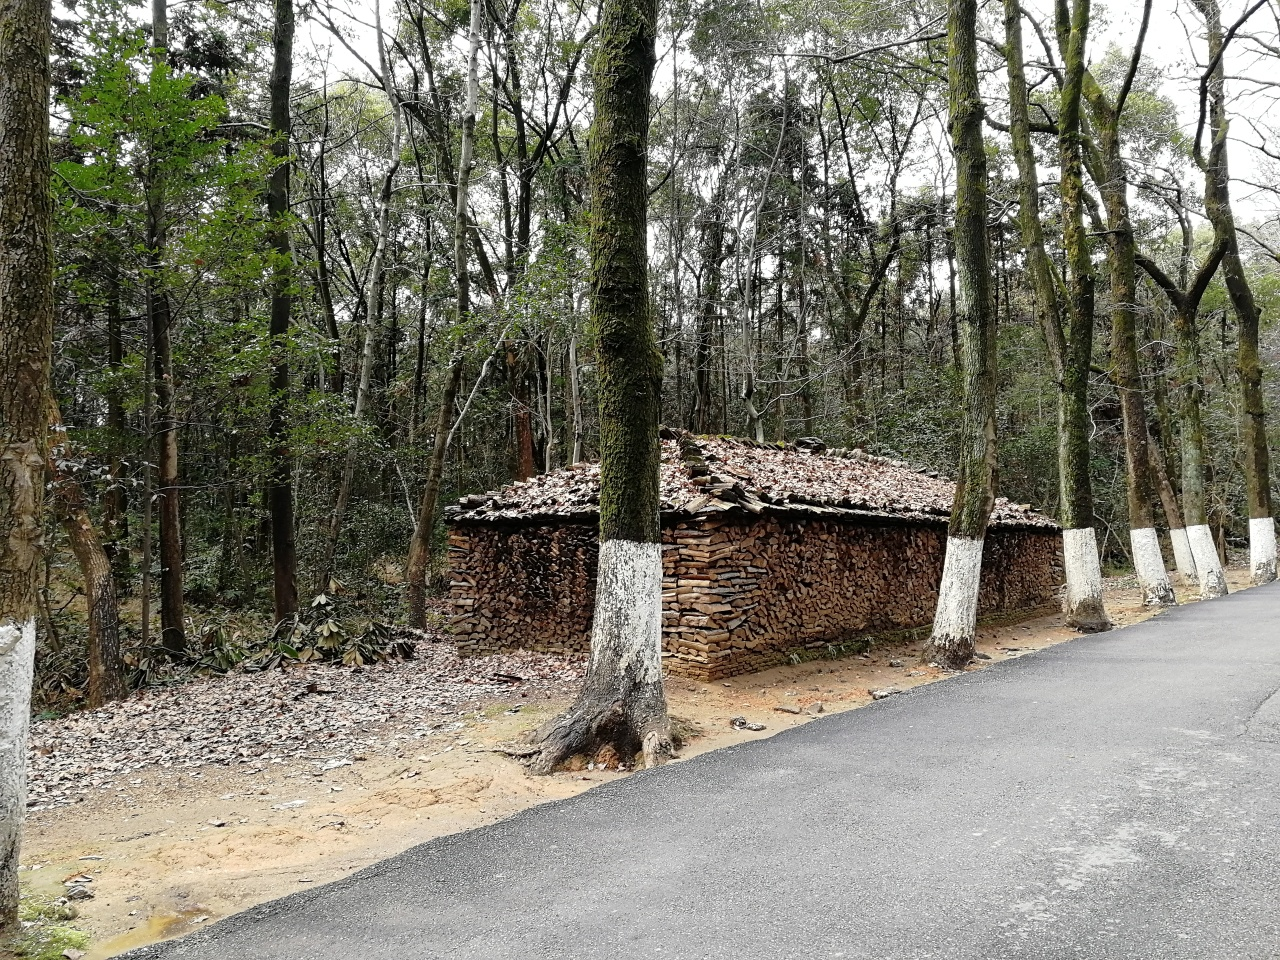What time of year does it appear to be in the image? The image seems to capture a time either in late autumn or early winter, as suggested by the leafless branches on several trees and the collection of fallen leaves on the roof of the woodpile shelter and scattered on the ground. 